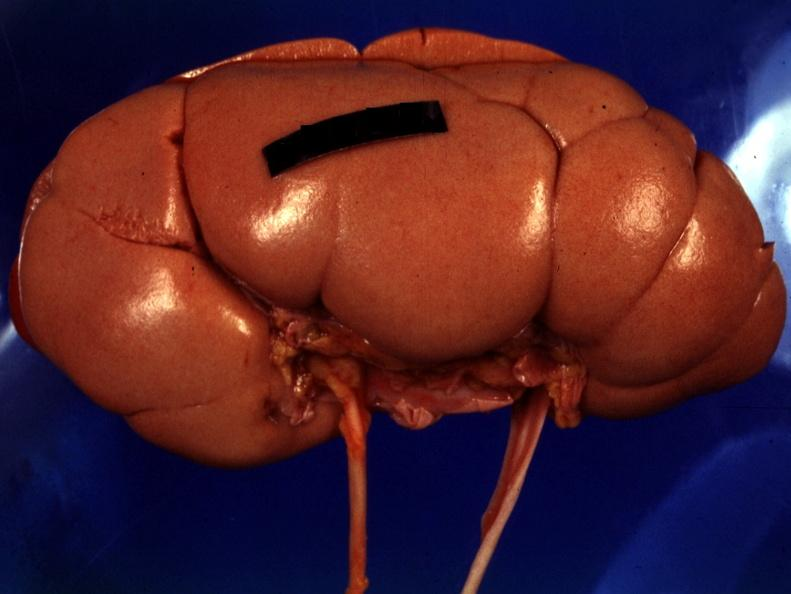s wound present?
Answer the question using a single word or phrase. No 